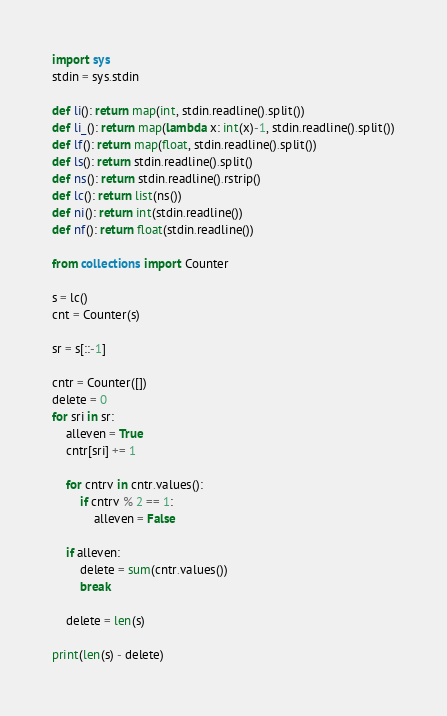<code> <loc_0><loc_0><loc_500><loc_500><_Python_>import sys
stdin = sys.stdin

def li(): return map(int, stdin.readline().split())
def li_(): return map(lambda x: int(x)-1, stdin.readline().split())
def lf(): return map(float, stdin.readline().split())
def ls(): return stdin.readline().split()
def ns(): return stdin.readline().rstrip()
def lc(): return list(ns())
def ni(): return int(stdin.readline())
def nf(): return float(stdin.readline())

from collections import Counter

s = lc()
cnt = Counter(s)

sr = s[::-1]

cntr = Counter([])
delete = 0
for sri in sr:
    alleven = True
    cntr[sri] += 1
    
    for cntrv in cntr.values():
        if cntrv % 2 == 1:
            alleven = False
            
    if alleven:
        delete = sum(cntr.values())
        break
    
    delete = len(s)
    
print(len(s) - delete)</code> 